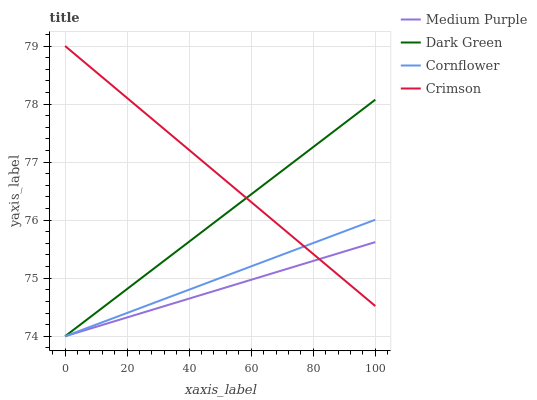Does Medium Purple have the minimum area under the curve?
Answer yes or no. Yes. Does Crimson have the maximum area under the curve?
Answer yes or no. Yes. Does Cornflower have the minimum area under the curve?
Answer yes or no. No. Does Cornflower have the maximum area under the curve?
Answer yes or no. No. Is Cornflower the smoothest?
Answer yes or no. Yes. Is Dark Green the roughest?
Answer yes or no. Yes. Is Crimson the smoothest?
Answer yes or no. No. Is Crimson the roughest?
Answer yes or no. No. Does Crimson have the lowest value?
Answer yes or no. No. Does Cornflower have the highest value?
Answer yes or no. No. 